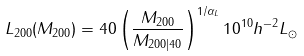Convert formula to latex. <formula><loc_0><loc_0><loc_500><loc_500>L _ { 2 0 0 } ( M _ { 2 0 0 } ) = 4 0 \left ( \frac { M _ { 2 0 0 } } { M _ { 2 0 0 | 4 0 } } \right ) ^ { 1 / \alpha _ { L } } 1 0 ^ { 1 0 } h ^ { - 2 } L _ { \odot }</formula> 